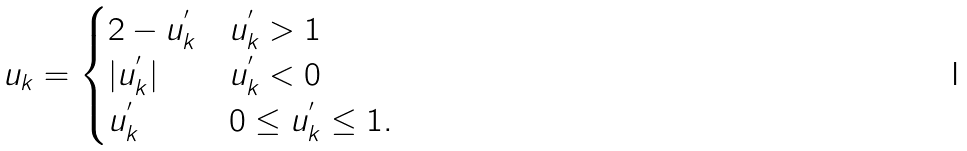Convert formula to latex. <formula><loc_0><loc_0><loc_500><loc_500>u _ { k } = \begin{cases} 2 - u _ { k } ^ { ^ { \prime } } & u _ { k } ^ { ^ { \prime } } > 1 \\ | u _ { k } ^ { ^ { \prime } } | & u _ { k } ^ { ^ { \prime } } < 0 \\ u _ { k } ^ { ^ { \prime } } & 0 \leq u _ { k } ^ { ^ { \prime } } \leq 1 . \end{cases}</formula> 